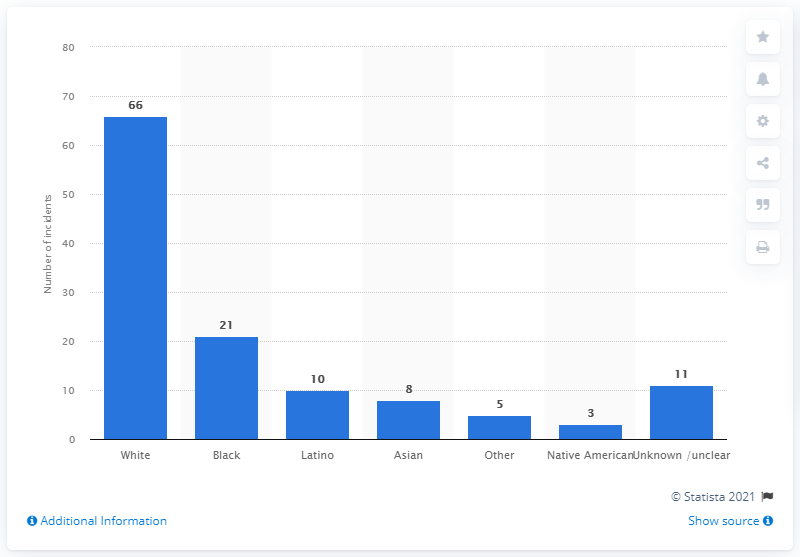List a handful of essential elements in this visual. It has been reported that white and black ethnicities have the highest number of mass shooters in the United States. The perpetrator of 10 mass shootings was Latino. In the United States, between 1982 and 2021, 66 of the 124 mass shootings were committed by white shooters. The bars in the graph are not sorted from left to right. 